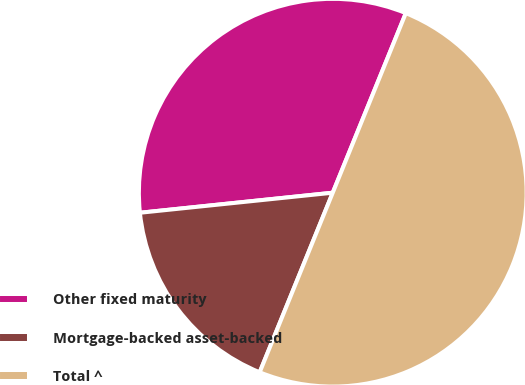Convert chart. <chart><loc_0><loc_0><loc_500><loc_500><pie_chart><fcel>Other fixed maturity<fcel>Mortgage-backed asset-backed<fcel>Total ^<nl><fcel>32.8%<fcel>17.2%<fcel>50.0%<nl></chart> 